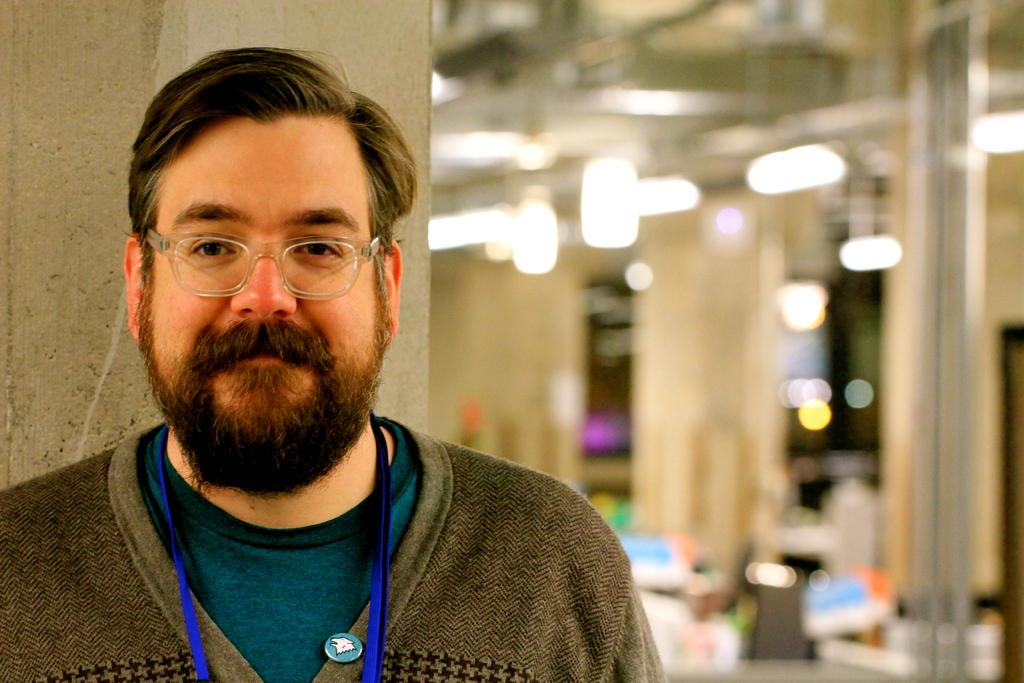What is the person in the image wearing? The person in the image is wearing spectacles. Can you describe the background of the image? The background of the image is blurry. What can be seen in the background of the image? There are lights visible in the background of the image. What brand of toothpaste is the person using in the image? There is no toothpaste present in the image, and the person's activities are not visible. 